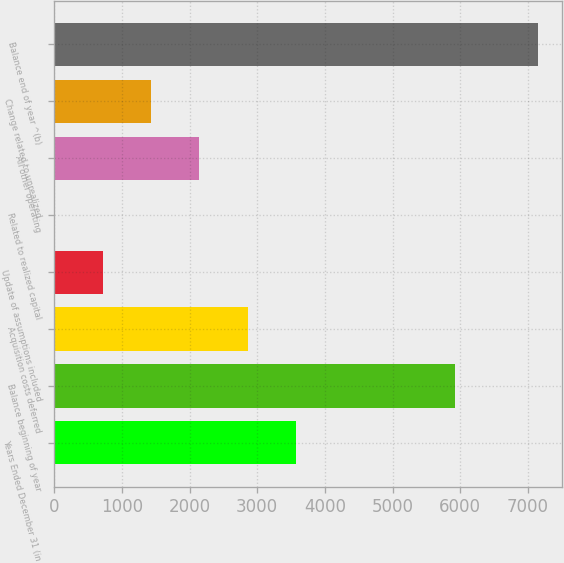Convert chart to OTSL. <chart><loc_0><loc_0><loc_500><loc_500><bar_chart><fcel>Years Ended December 31 (in<fcel>Balance beginning of year<fcel>Acquisition costs deferred<fcel>Update of assumptions included<fcel>Related to realized capital<fcel>All other operating<fcel>Change related to unrealized<fcel>Balance end of year ^(b)<nl><fcel>3575.5<fcel>5928<fcel>2860.8<fcel>716.7<fcel>2<fcel>2146.1<fcel>1431.4<fcel>7149<nl></chart> 